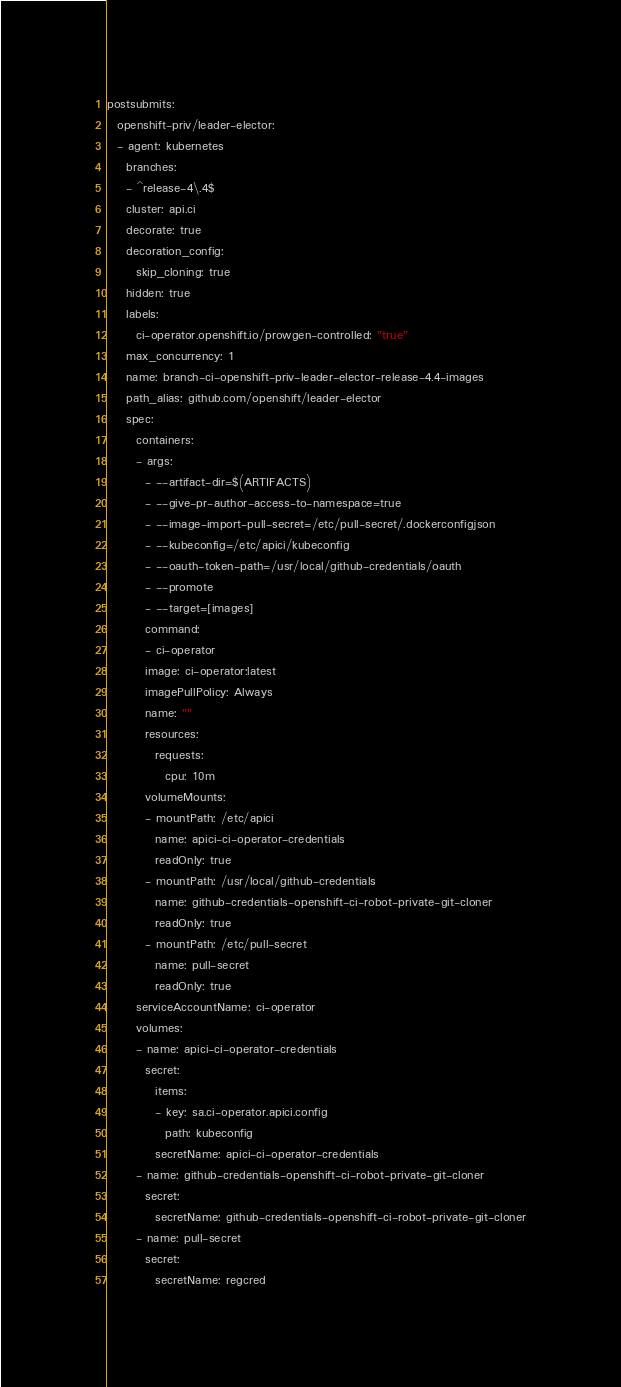Convert code to text. <code><loc_0><loc_0><loc_500><loc_500><_YAML_>postsubmits:
  openshift-priv/leader-elector:
  - agent: kubernetes
    branches:
    - ^release-4\.4$
    cluster: api.ci
    decorate: true
    decoration_config:
      skip_cloning: true
    hidden: true
    labels:
      ci-operator.openshift.io/prowgen-controlled: "true"
    max_concurrency: 1
    name: branch-ci-openshift-priv-leader-elector-release-4.4-images
    path_alias: github.com/openshift/leader-elector
    spec:
      containers:
      - args:
        - --artifact-dir=$(ARTIFACTS)
        - --give-pr-author-access-to-namespace=true
        - --image-import-pull-secret=/etc/pull-secret/.dockerconfigjson
        - --kubeconfig=/etc/apici/kubeconfig
        - --oauth-token-path=/usr/local/github-credentials/oauth
        - --promote
        - --target=[images]
        command:
        - ci-operator
        image: ci-operator:latest
        imagePullPolicy: Always
        name: ""
        resources:
          requests:
            cpu: 10m
        volumeMounts:
        - mountPath: /etc/apici
          name: apici-ci-operator-credentials
          readOnly: true
        - mountPath: /usr/local/github-credentials
          name: github-credentials-openshift-ci-robot-private-git-cloner
          readOnly: true
        - mountPath: /etc/pull-secret
          name: pull-secret
          readOnly: true
      serviceAccountName: ci-operator
      volumes:
      - name: apici-ci-operator-credentials
        secret:
          items:
          - key: sa.ci-operator.apici.config
            path: kubeconfig
          secretName: apici-ci-operator-credentials
      - name: github-credentials-openshift-ci-robot-private-git-cloner
        secret:
          secretName: github-credentials-openshift-ci-robot-private-git-cloner
      - name: pull-secret
        secret:
          secretName: regcred
</code> 